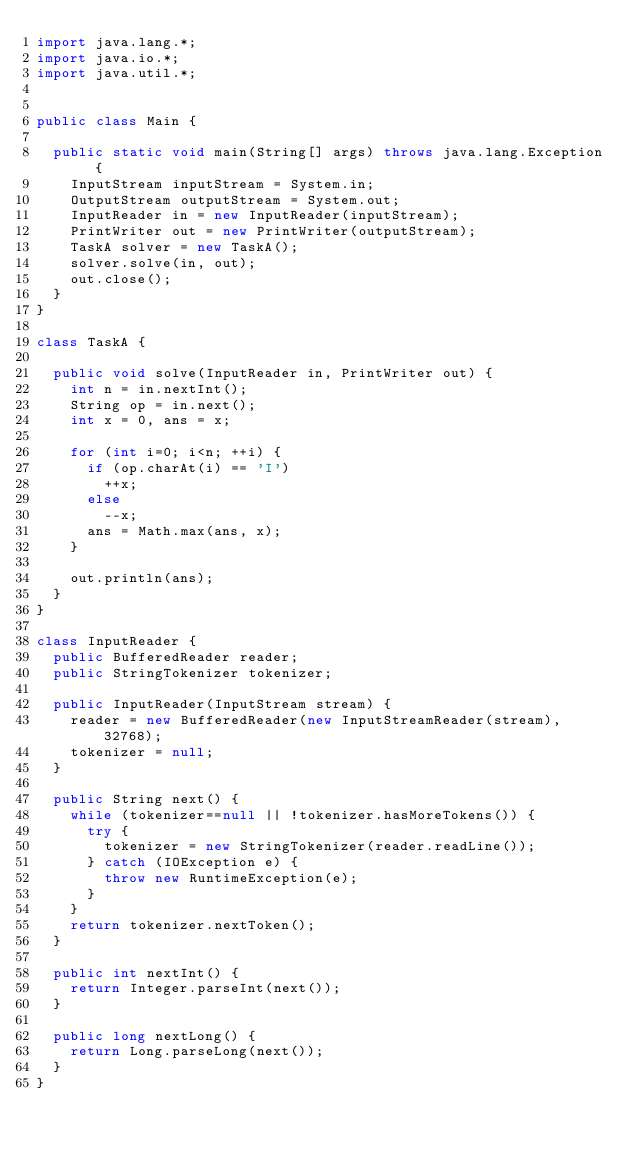Convert code to text. <code><loc_0><loc_0><loc_500><loc_500><_Java_>import java.lang.*;
import java.io.*;
import java.util.*;


public class Main {
	
	public static void main(String[] args) throws java.lang.Exception {
		InputStream inputStream = System.in;
		OutputStream outputStream = System.out;
		InputReader in = new InputReader(inputStream);
		PrintWriter out = new PrintWriter(outputStream);
		TaskA solver = new TaskA();
		solver.solve(in, out);
		out.close();
	}
}

class TaskA {
	
	public void solve(InputReader in, PrintWriter out) {
		int n = in.nextInt();
		String op = in.next();
		int x = 0, ans = x;
		
		for (int i=0; i<n; ++i) {
			if (op.charAt(i) == 'I')
				++x;
			else
				--x;
			ans = Math.max(ans, x);
		}
		
		out.println(ans);
	}
}

class InputReader {
	public BufferedReader reader;
	public StringTokenizer tokenizer;
	
	public InputReader(InputStream stream) {
		reader = new BufferedReader(new InputStreamReader(stream), 32768);
		tokenizer = null;
	}
	
	public String next() {
		while (tokenizer==null || !tokenizer.hasMoreTokens()) {
			try {
				tokenizer = new StringTokenizer(reader.readLine());
			} catch (IOException e) {
				throw new RuntimeException(e);
			}
		}
		return tokenizer.nextToken();
	}
	
	public int nextInt() {
		return Integer.parseInt(next());
	}
	
	public long nextLong() {
		return Long.parseLong(next());
	}
}
</code> 